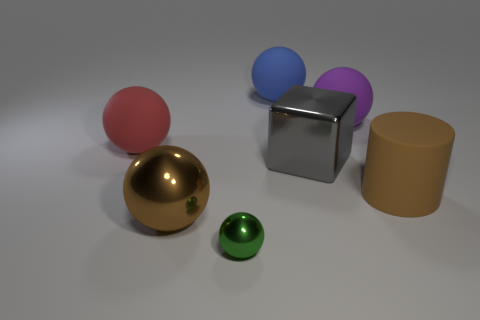How many other things are the same shape as the red thing?
Make the answer very short. 4. Do the green metallic object and the big metal thing that is behind the brown metallic thing have the same shape?
Provide a succinct answer. No. There is a metallic object that is the same color as the big matte cylinder; what is its shape?
Give a very brief answer. Sphere. Is there a sphere that has the same material as the big purple thing?
Offer a very short reply. Yes. Is there anything else that has the same material as the green ball?
Offer a terse response. Yes. What is the large sphere in front of the big matte sphere that is left of the small metallic ball made of?
Give a very brief answer. Metal. How big is the brown thing that is to the left of the brown object to the right of the rubber ball on the right side of the large metallic cube?
Your answer should be very brief. Large. What number of other things are there of the same shape as the purple rubber object?
Offer a terse response. 4. Is the color of the matte sphere that is to the left of the green metal thing the same as the big shiny object right of the blue thing?
Ensure brevity in your answer.  No. The metal ball that is the same size as the red rubber sphere is what color?
Your answer should be compact. Brown. 